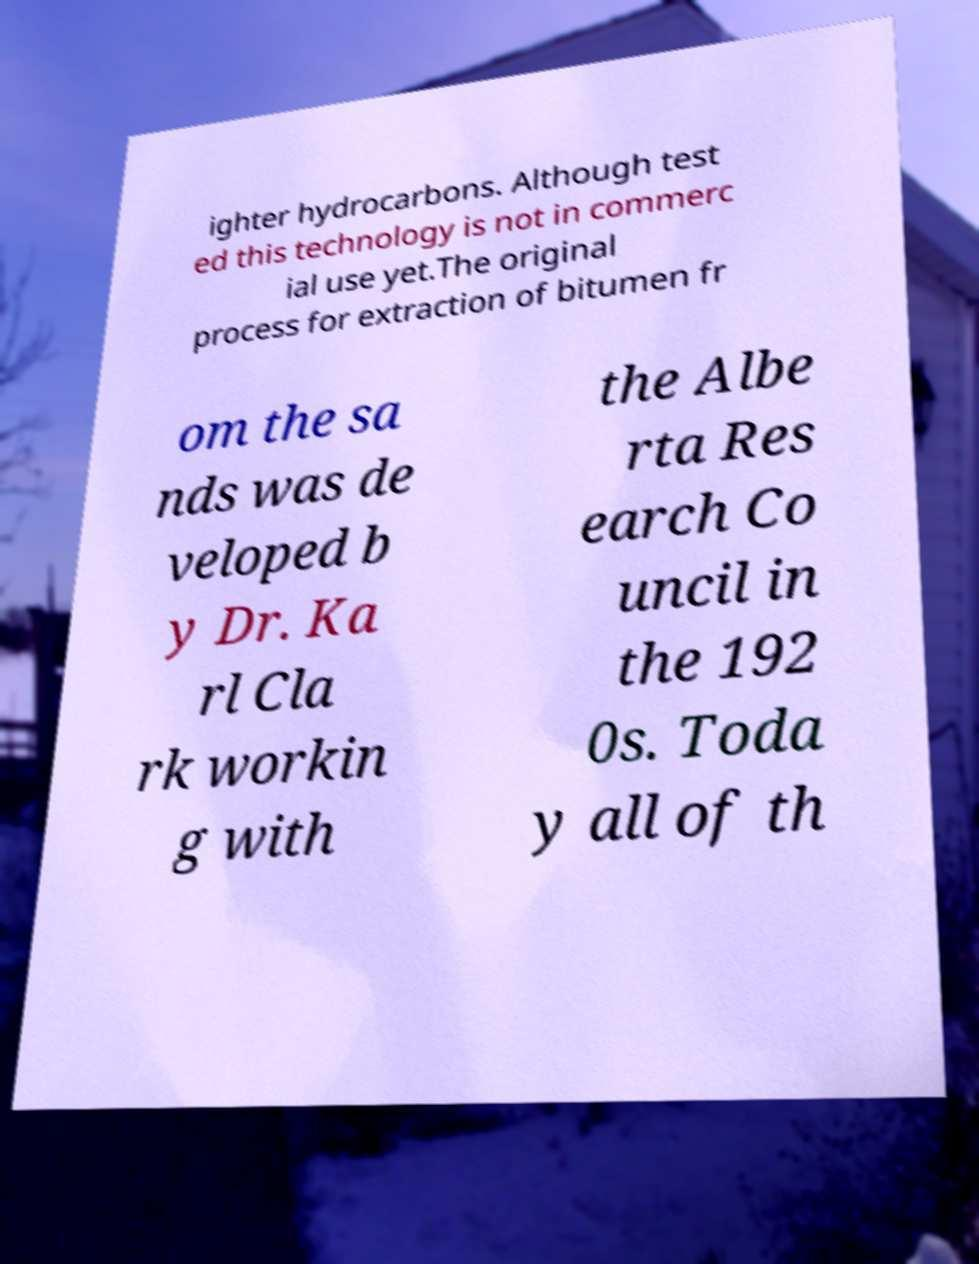There's text embedded in this image that I need extracted. Can you transcribe it verbatim? ighter hydrocarbons. Although test ed this technology is not in commerc ial use yet.The original process for extraction of bitumen fr om the sa nds was de veloped b y Dr. Ka rl Cla rk workin g with the Albe rta Res earch Co uncil in the 192 0s. Toda y all of th 